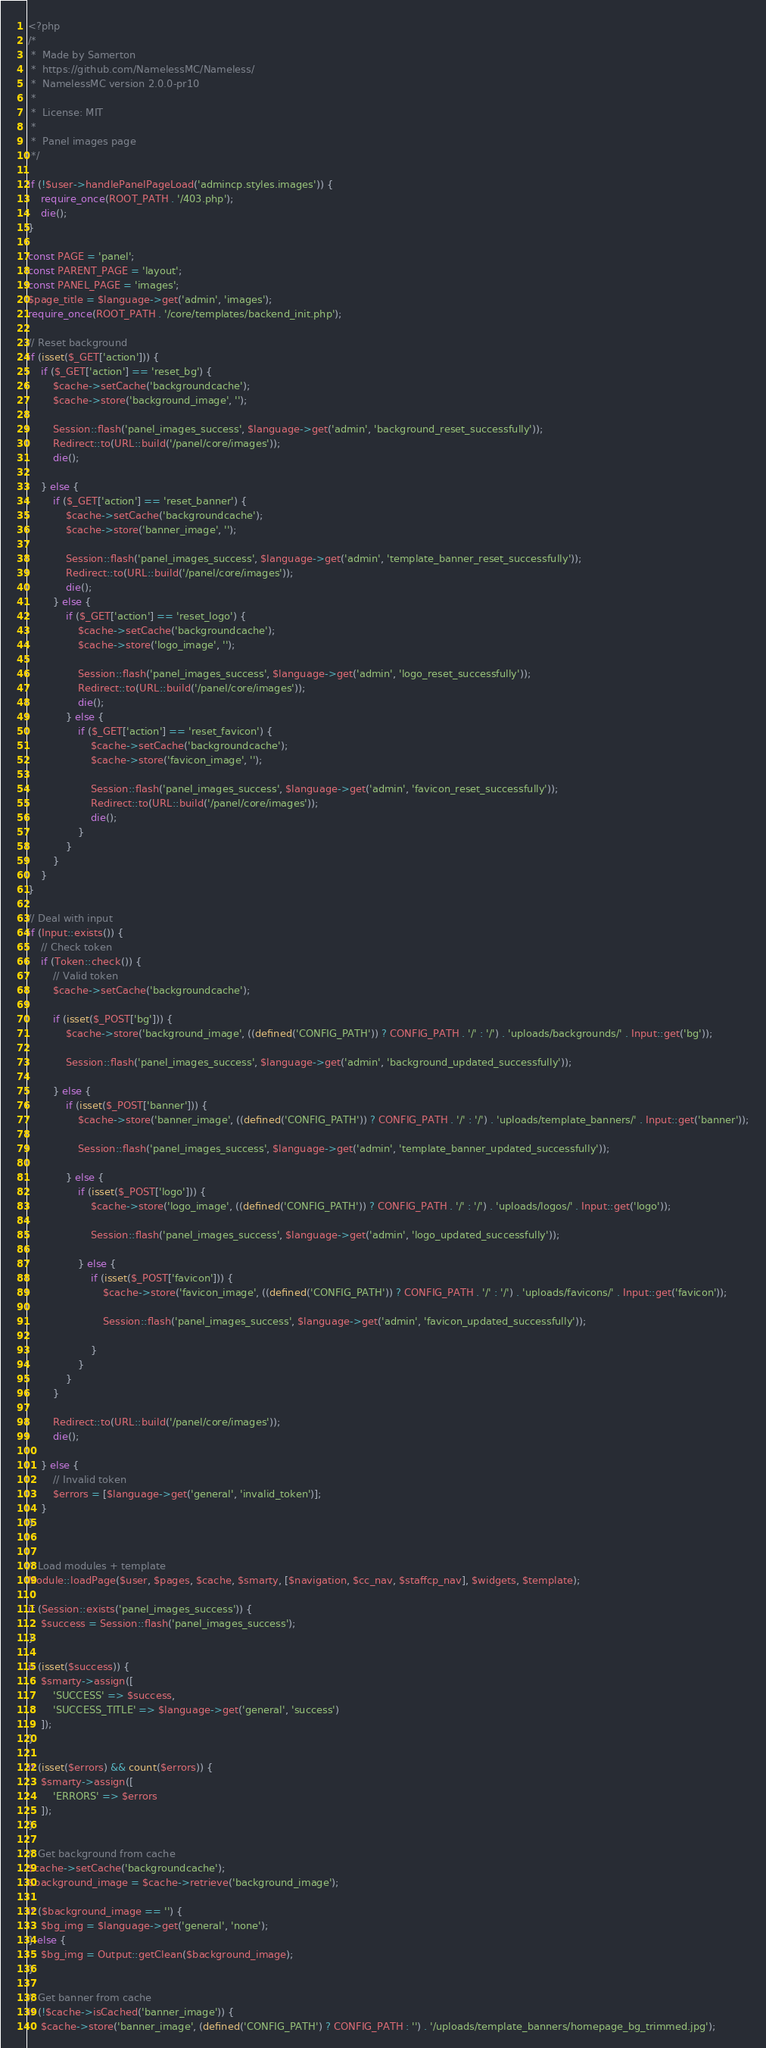Convert code to text. <code><loc_0><loc_0><loc_500><loc_500><_PHP_><?php
/*
 *	Made by Samerton
 *  https://github.com/NamelessMC/Nameless/
 *  NamelessMC version 2.0.0-pr10
 *
 *  License: MIT
 *
 *  Panel images page
 */

if (!$user->handlePanelPageLoad('admincp.styles.images')) {
    require_once(ROOT_PATH . '/403.php');
    die();
}

const PAGE = 'panel';
const PARENT_PAGE = 'layout';
const PANEL_PAGE = 'images';
$page_title = $language->get('admin', 'images');
require_once(ROOT_PATH . '/core/templates/backend_init.php');

// Reset background
if (isset($_GET['action'])) {
    if ($_GET['action'] == 'reset_bg') {
        $cache->setCache('backgroundcache');
        $cache->store('background_image', '');

        Session::flash('panel_images_success', $language->get('admin', 'background_reset_successfully'));
        Redirect::to(URL::build('/panel/core/images'));
        die();

    } else {
        if ($_GET['action'] == 'reset_banner') {
            $cache->setCache('backgroundcache');
            $cache->store('banner_image', '');

            Session::flash('panel_images_success', $language->get('admin', 'template_banner_reset_successfully'));
            Redirect::to(URL::build('/panel/core/images'));
            die();
        } else {
            if ($_GET['action'] == 'reset_logo') {
                $cache->setCache('backgroundcache');
                $cache->store('logo_image', '');

                Session::flash('panel_images_success', $language->get('admin', 'logo_reset_successfully'));
                Redirect::to(URL::build('/panel/core/images'));
                die();
            } else {
                if ($_GET['action'] == 'reset_favicon') {
                    $cache->setCache('backgroundcache');
                    $cache->store('favicon_image', '');

                    Session::flash('panel_images_success', $language->get('admin', 'favicon_reset_successfully'));
                    Redirect::to(URL::build('/panel/core/images'));
                    die();
                }
            }
        }
    }
}

// Deal with input
if (Input::exists()) {
    // Check token
    if (Token::check()) {
        // Valid token
        $cache->setCache('backgroundcache');

        if (isset($_POST['bg'])) {
            $cache->store('background_image', ((defined('CONFIG_PATH')) ? CONFIG_PATH . '/' : '/') . 'uploads/backgrounds/' . Input::get('bg'));

            Session::flash('panel_images_success', $language->get('admin', 'background_updated_successfully'));

        } else {
            if (isset($_POST['banner'])) {
                $cache->store('banner_image', ((defined('CONFIG_PATH')) ? CONFIG_PATH . '/' : '/') . 'uploads/template_banners/' . Input::get('banner'));

                Session::flash('panel_images_success', $language->get('admin', 'template_banner_updated_successfully'));

            } else {
                if (isset($_POST['logo'])) {
                    $cache->store('logo_image', ((defined('CONFIG_PATH')) ? CONFIG_PATH . '/' : '/') . 'uploads/logos/' . Input::get('logo'));

                    Session::flash('panel_images_success', $language->get('admin', 'logo_updated_successfully'));

                } else {
                    if (isset($_POST['favicon'])) {
                        $cache->store('favicon_image', ((defined('CONFIG_PATH')) ? CONFIG_PATH . '/' : '/') . 'uploads/favicons/' . Input::get('favicon'));

                        Session::flash('panel_images_success', $language->get('admin', 'favicon_updated_successfully'));

                    }
                }
            }
        }

        Redirect::to(URL::build('/panel/core/images'));
        die();

    } else {
        // Invalid token
        $errors = [$language->get('general', 'invalid_token')];
    }
}


// Load modules + template
Module::loadPage($user, $pages, $cache, $smarty, [$navigation, $cc_nav, $staffcp_nav], $widgets, $template);

if (Session::exists('panel_images_success')) {
    $success = Session::flash('panel_images_success');
}

if (isset($success)) {
    $smarty->assign([
        'SUCCESS' => $success,
        'SUCCESS_TITLE' => $language->get('general', 'success')
    ]);
}

if (isset($errors) && count($errors)) {
    $smarty->assign([
        'ERRORS' => $errors
    ]);
}

// Get background from cache
$cache->setCache('backgroundcache');
$background_image = $cache->retrieve('background_image');

if ($background_image == '') {
    $bg_img = $language->get('general', 'none');
} else {
    $bg_img = Output::getClean($background_image);
}

// Get banner from cache
if (!$cache->isCached('banner_image')) {
    $cache->store('banner_image', (defined('CONFIG_PATH') ? CONFIG_PATH : '') . '/uploads/template_banners/homepage_bg_trimmed.jpg');</code> 